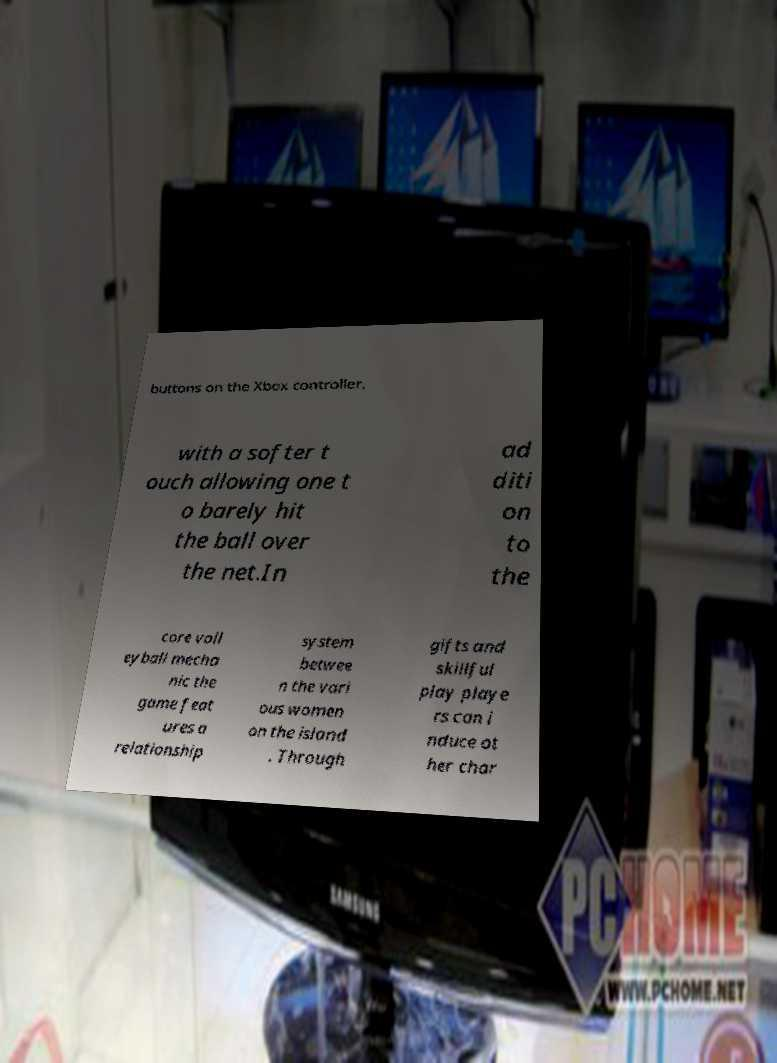I need the written content from this picture converted into text. Can you do that? buttons on the Xbox controller, with a softer t ouch allowing one t o barely hit the ball over the net.In ad diti on to the core voll eyball mecha nic the game feat ures a relationship system betwee n the vari ous women on the island . Through gifts and skillful play playe rs can i nduce ot her char 